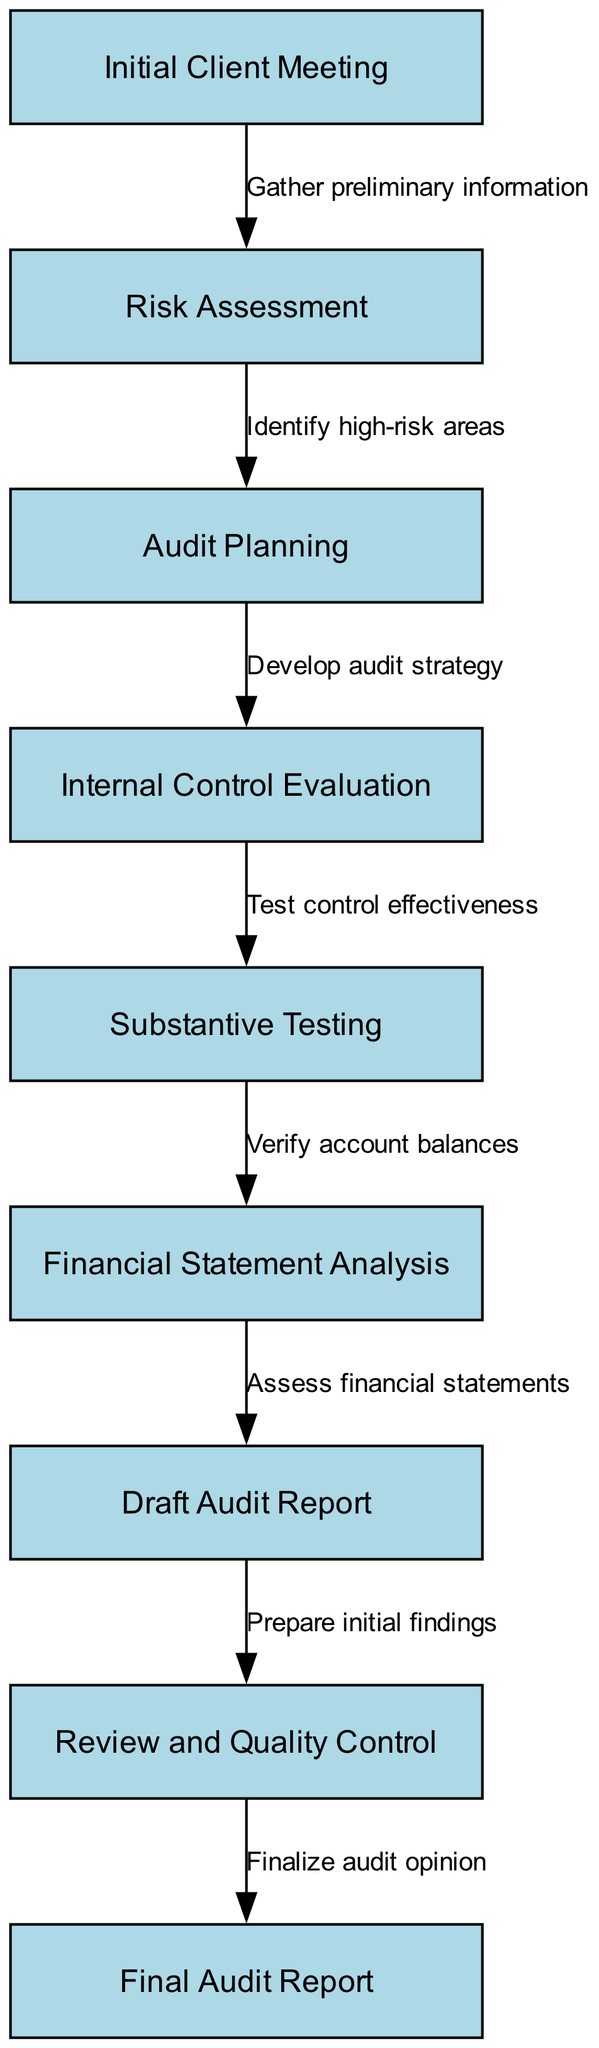What is the first step in the financial audit process? The first node in the diagram represents the initial step, which is the "Initial Client Meeting." This is the starting point of the audit process.
Answer: Initial Client Meeting How many nodes are in the financial audit process diagram? To find the total number of nodes, we count all the unique steps represented in the diagram. There are nine nodes in total.
Answer: 9 What is the relationship between "Risk Assessment" and "Audit Planning"? The edge connecting "Risk Assessment" to "Audit Planning" indicates that an audit strategy is developed based on identifying high-risk areas during the risk assessment.
Answer: Develop audit strategy Which step directly follows "Substantive Testing"? The diagram shows that "Substantive Testing" is followed directly by "Financial Statement Analysis," indicating the sequence of steps in the audit process.
Answer: Financial Statement Analysis What is the last step before the "Final Audit Report"? The edge leading to the "Final Audit Report" indicates that the previous step is the "Review and Quality Control," which involves finalizing audit findings before the final report is issued.
Answer: Review and Quality Control How does "Initial Client Meeting" relate to the overall process? It serves as the starting point, providing vital preliminary information needed for the subsequent steps such as risk assessment and audit planning.
Answer: Starting point What action is taken during "Internal Control Evaluation"? The edge from "Internal Control Evaluation" to "Substantive Testing" explains that control effectiveness is tested as part of this evaluation step.
Answer: Test control effectiveness Which step concludes the financial audit process? The final node in the chart is "Final Audit Report," which represents the conclusion of the audit process.
Answer: Final Audit Report How many edges connect the nodes in the financial audit process? By counting the connections between the steps, we find that there are eight edges connecting the nine nodes in the process diagram.
Answer: 8 